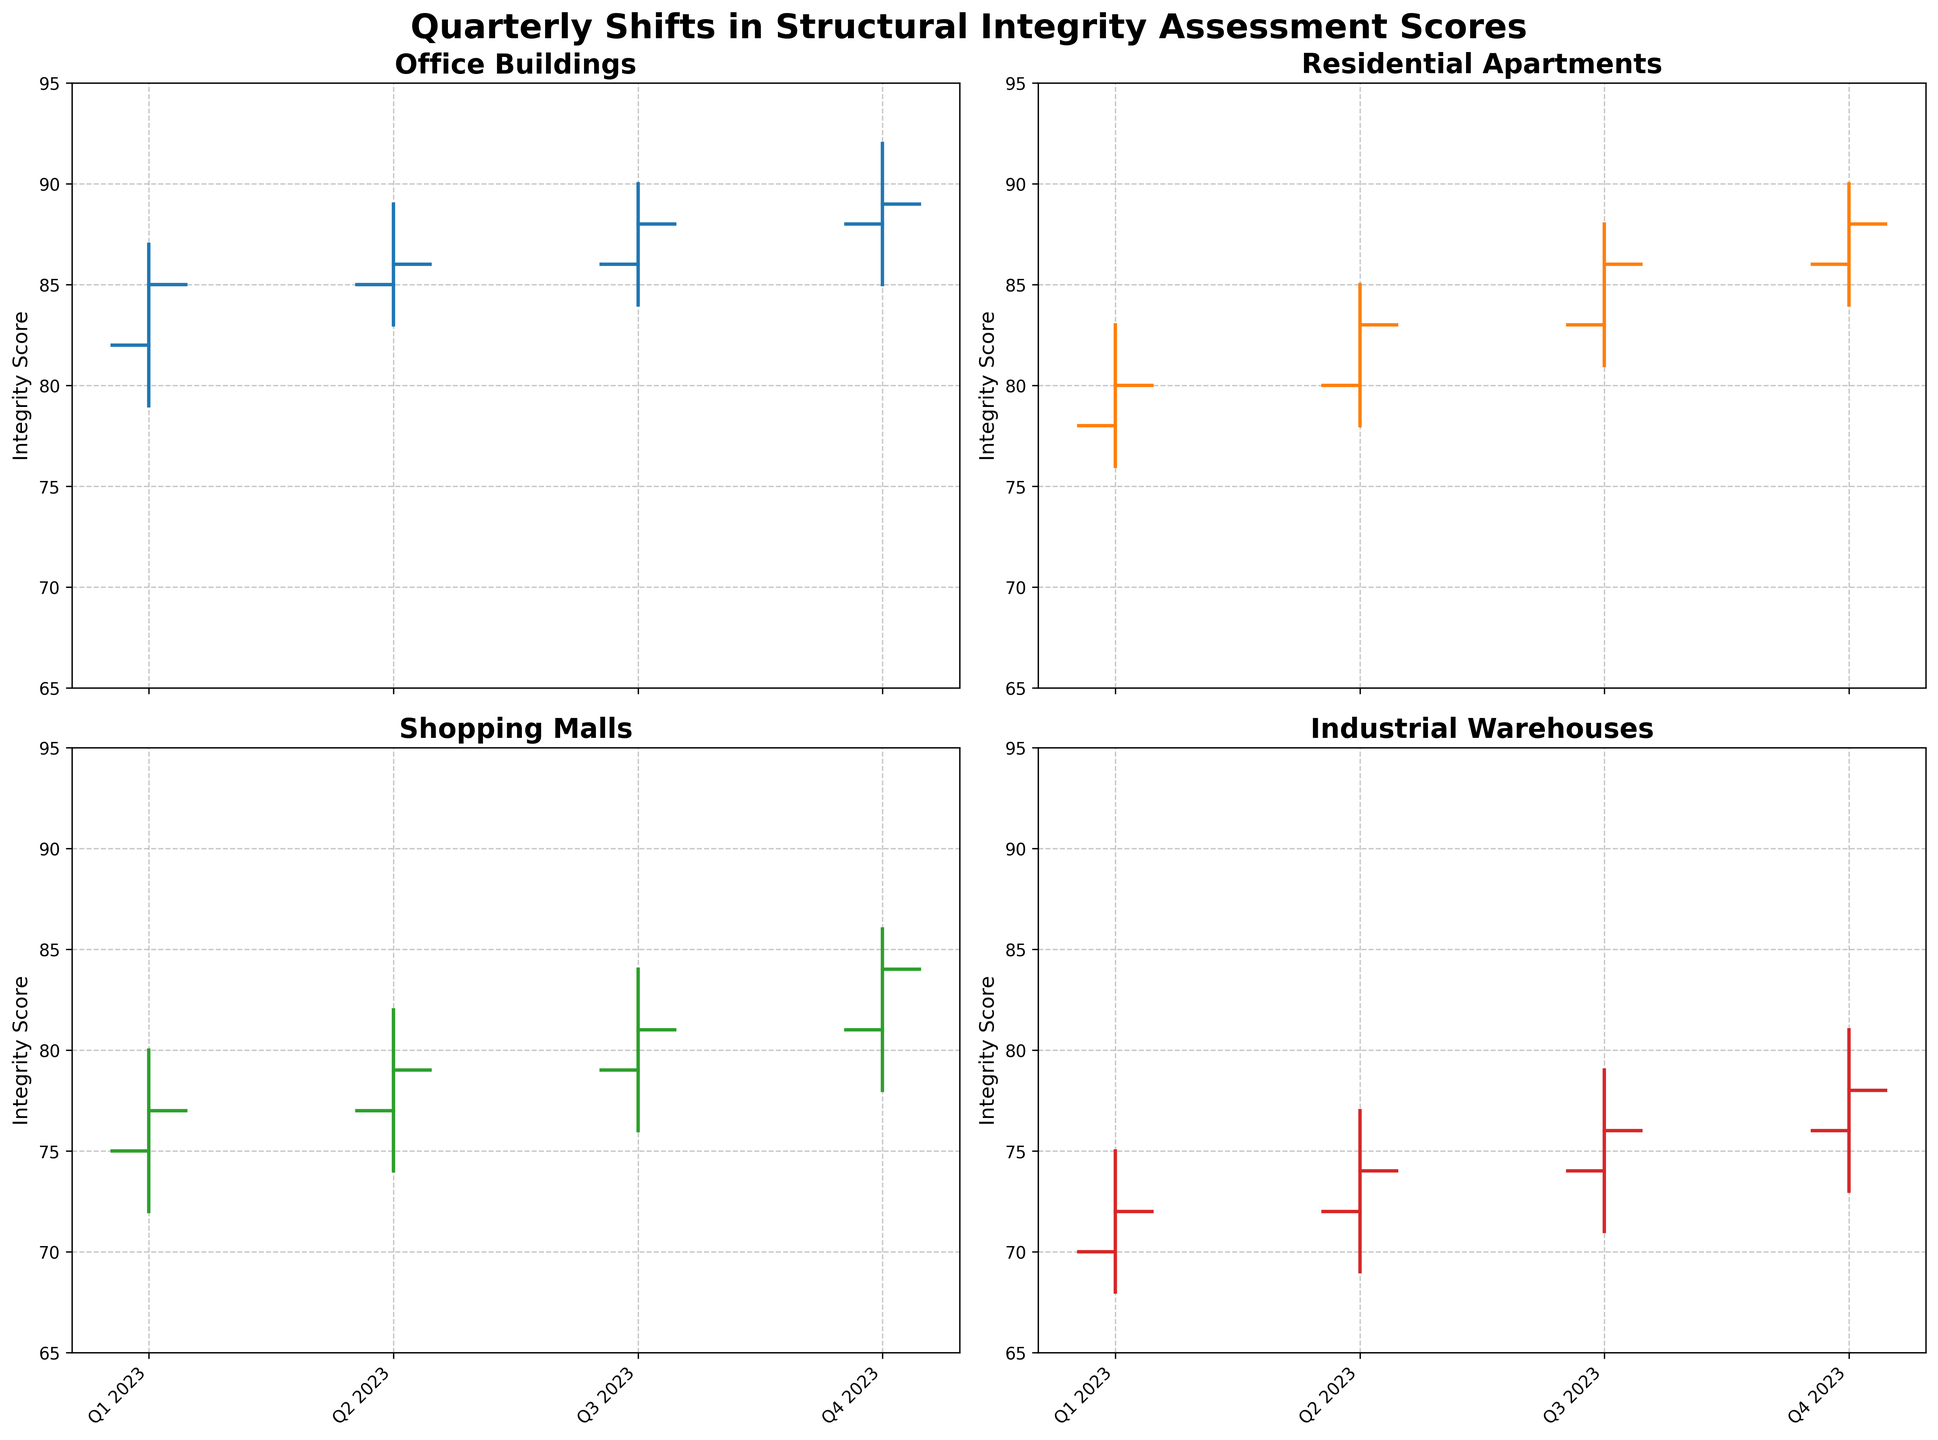What is the title of the figure? The title is mentioned at the top of the figure in bold font. It states the main topic or content illustrated by the charts.
Answer: Quarterly Shifts in Structural Integrity Assessment Scores Which building type shows the highest integrity score in Q4 2023? To determine this, look at the highest values in Q4 2023 across all building types. The highest values are shown as the top of the vertical lines in the OHLC charts.
Answer: Office Buildings How many quarters are represented in the charts? Each chart displays data for the year 2023, segmented by quarters (Q1, Q2, Q3, Q4). By counting the labels on the x-axis, we can verify the number of quarters.
Answer: 4 What is the integrity score range for Industrial Warehouses in Q2 2023? Look at the vertical line for Industrial Warehouses in Q2 2023. The range can be determined by noting the low and high points, which are marked by the ends of the vertical line.
Answer: 69 to 77 Which building type has the most significant increase in integrity score from Q1 to Q4 2023? To determine this, check the opening score of Q1 2023 and the closing score of Q4 2023 for each building type. The building type with the highest positive difference indicates the most significant increase.
Answer: Office Buildings What is the integrity score range for Residential Apartments in Q3 2023? Examine the vertical line for Residential Apartments in Q3 2023. Identify the low (81) and high (88) points to determine the range.
Answer: 81 to 88 Compare the closing scores of Shopping Malls and Industrial Warehouses in Q4 2023. Which is higher? Identify the closing scores in Q4 2023 for both Shopping Malls (84) and Industrial Warehouses (78). Then, compare to determine which is higher.
Answer: Shopping Malls How did the integrity score for Office Buildings change from Q3 to Q4 2023? Look at the closing value of Q3 2023 (88) and the closing value of Q4 2023 (89) for Office Buildings. Assess the difference in these values.
Answer: Increased by 1 What is the difference between the highest and lowest integrity scores for each building type in Q1 2023? For each building type, in Q1 2023, subtract the lowest score (low) from the highest score (high) to get the difference: Office Buildings (87-79), Residential Apartments (83-76), Shopping Malls (80-72), Industrial Warehouses (75-68).
Answer: Office: 8, Residential: 7, Shopping: 8, Industrial: 7 